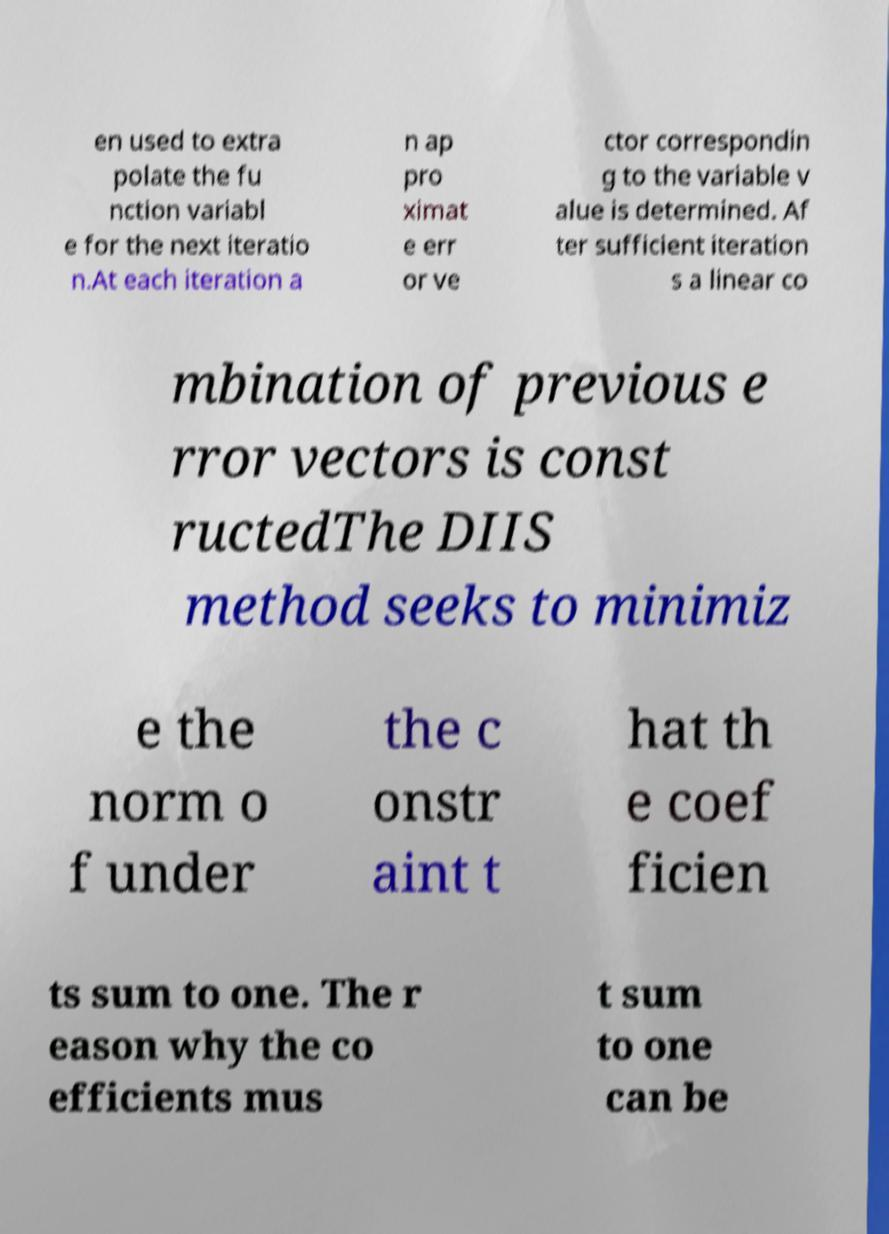Can you read and provide the text displayed in the image?This photo seems to have some interesting text. Can you extract and type it out for me? en used to extra polate the fu nction variabl e for the next iteratio n.At each iteration a n ap pro ximat e err or ve ctor correspondin g to the variable v alue is determined. Af ter sufficient iteration s a linear co mbination of previous e rror vectors is const ructedThe DIIS method seeks to minimiz e the norm o f under the c onstr aint t hat th e coef ficien ts sum to one. The r eason why the co efficients mus t sum to one can be 